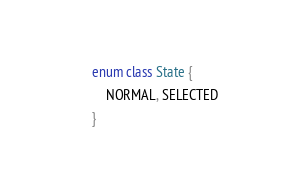<code> <loc_0><loc_0><loc_500><loc_500><_Kotlin_>enum class State {
    NORMAL, SELECTED
}</code> 